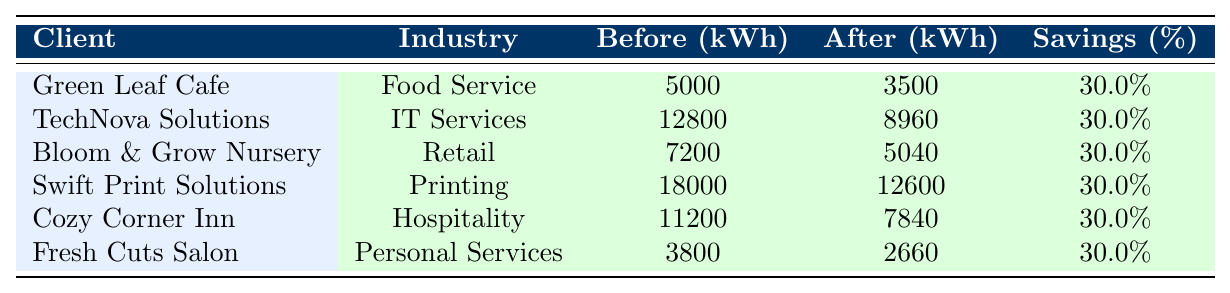What was the energy consumption in kWh for Green Leaf Cafe before implementation? The table indicates that the monthly energy consumption for Green Leaf Cafe before implementation was 5000 kWh.
Answer: 5000 kWh How much did TechNova Solutions save in monthly energy costs after implementation? According to the table, TechNova Solutions' monthly energy cost before was $3200, and after implementation, it became $2240. The savings are calculated as $3200 - $2240 = $960.
Answer: $960 Did Cozy Corner Inn achieve energy consumption savings after implementing energy-efficient solutions? The table shows that Cozy Corner Inn had a monthly energy consumption of 11200 kWh before and 7840 kWh after, indicating a reduction in energy consumption. Therefore, the answer is yes.
Answer: Yes What is the percentage savings in energy consumption for Fresh Cuts Salon? Fresh Cuts Salon had energy consumption of 3800 kWh before and 2660 kWh after implementation. The savings in kWh is (3800 - 2660) = 1140 kWh. To find the percentage savings, divide the savings by the initial consumption and multiply by 100: (1140 / 3800) * 100 = 30%.
Answer: 30% Which client had the highest monthly energy cost before implementation? By reviewing the monthly energy costs before implementation, Swift Print Solutions' cost was $4500, which is higher than any other client's cost listed in the table.
Answer: Swift Print Solutions How many clients implemented LED lighting as part of their energy-efficient solutions? The table shows that Green Leaf Cafe, Bloom & Grow Nursery, and Fresh Cuts Salon implemented LED lighting. Therefore, the count of clients using LED lighting is 3.
Answer: 3 What was the average monthly energy cost after implementation across all clients? The monthly energy costs after implementation for all clients are $875, $2240, $1260, $3150, $1960, and $665. Adding these together gives $875 + $2240 + $1260 + $3150 + $1960 + $665 = $10910. Dividing this sum by the number of clients (6) gives $10910 / 6 = $1818.33.
Answer: $1818.33 Is the percentage savings consistent across all clients listed in the table? The table indicates that all clients achieve a 30% savings in energy consumption, which shows that the percentage savings is indeed consistent across all clients.
Answer: Yes What is the difference in monthly energy cost savings between Swift Print Solutions and Cozy Corner Inn after implementation? Cozy Corner Inn's monthly energy cost after implementation is $1960, while Swift Print Solutions' is $3150. The difference in monthly energy costs is $3150 - $1960 = $1190.
Answer: $1190 Which industry saw the lowest energy cost before implementation? Reviewing the table, Fresh Cuts Salon from the Personal Services industry had the lowest monthly energy cost before implementation, which was $950.
Answer: Personal Services 